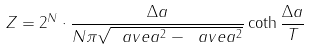<formula> <loc_0><loc_0><loc_500><loc_500>Z = 2 ^ { N } \cdot \frac { \Delta a } { N \pi \sqrt { \ a v e { a ^ { 2 } } - \ a v e { a } ^ { 2 } } } \coth { \frac { \Delta a } { T } }</formula> 